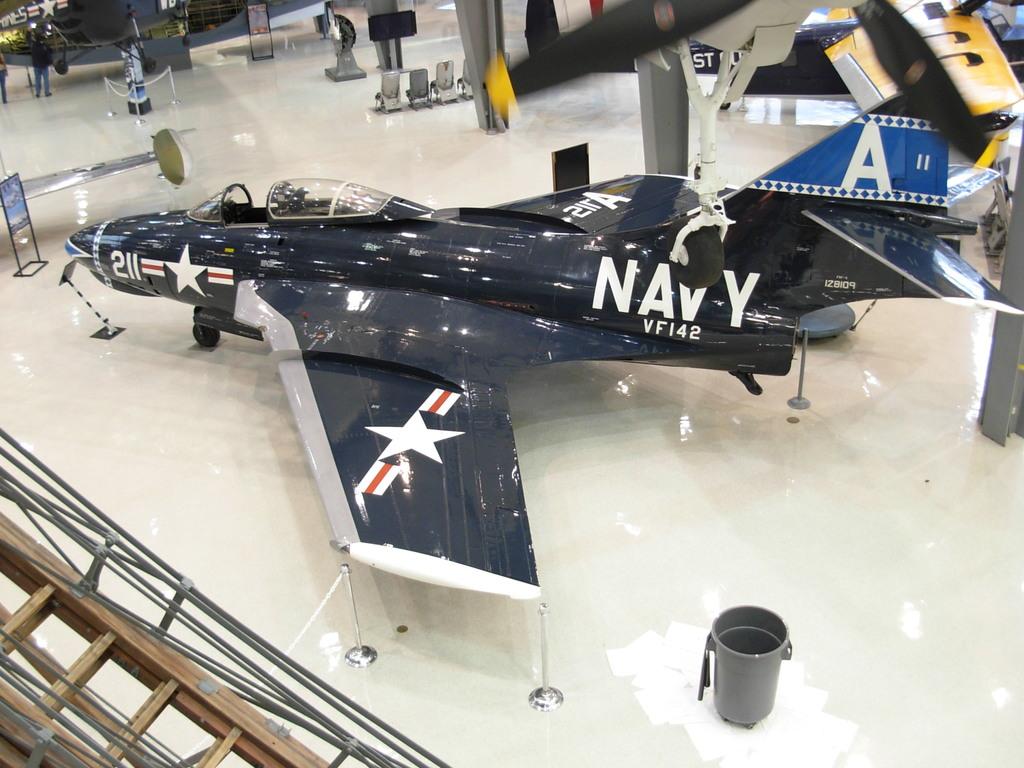What branch is this plane from?
Your response must be concise. Navy. 